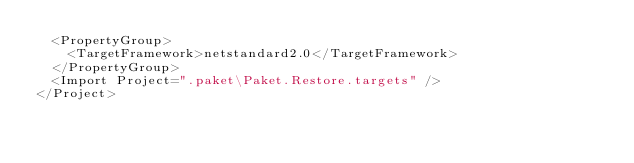<code> <loc_0><loc_0><loc_500><loc_500><_XML_>  <PropertyGroup>
    <TargetFramework>netstandard2.0</TargetFramework>
  </PropertyGroup>
  <Import Project=".paket\Paket.Restore.targets" />
</Project>
</code> 